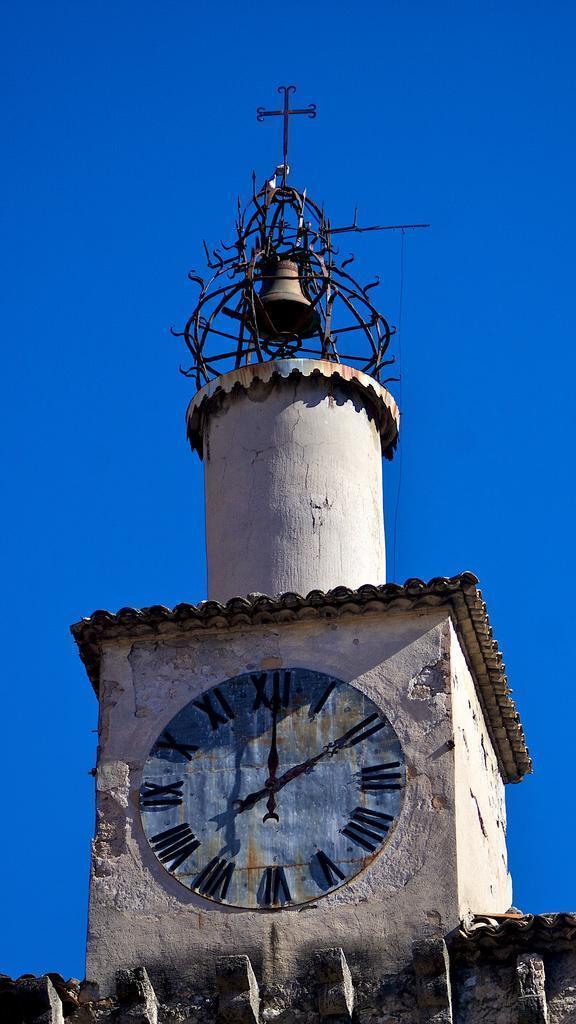How many clock faces are there?
Give a very brief answer. 1. 